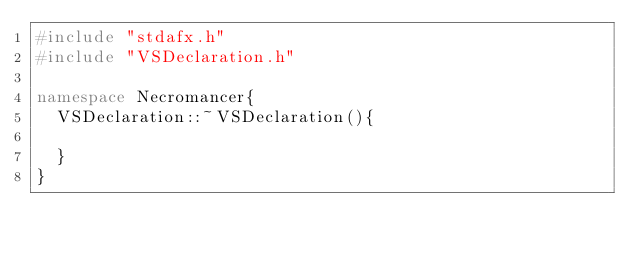Convert code to text. <code><loc_0><loc_0><loc_500><loc_500><_C++_>#include "stdafx.h"
#include "VSDeclaration.h"

namespace Necromancer{
	VSDeclaration::~VSDeclaration(){

	}
}</code> 